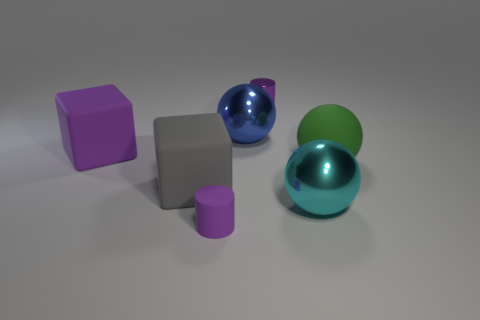Subtract all cyan metal balls. How many balls are left? 2 Subtract all cyan balls. How many balls are left? 2 Subtract all spheres. How many objects are left? 4 Add 2 rubber cylinders. How many objects exist? 9 Subtract 0 purple balls. How many objects are left? 7 Subtract all purple spheres. Subtract all cyan blocks. How many spheres are left? 3 Subtract all red balls. How many purple blocks are left? 1 Subtract all purple metallic objects. Subtract all big red cylinders. How many objects are left? 6 Add 6 large shiny things. How many large shiny things are left? 8 Add 4 brown metal cylinders. How many brown metal cylinders exist? 4 